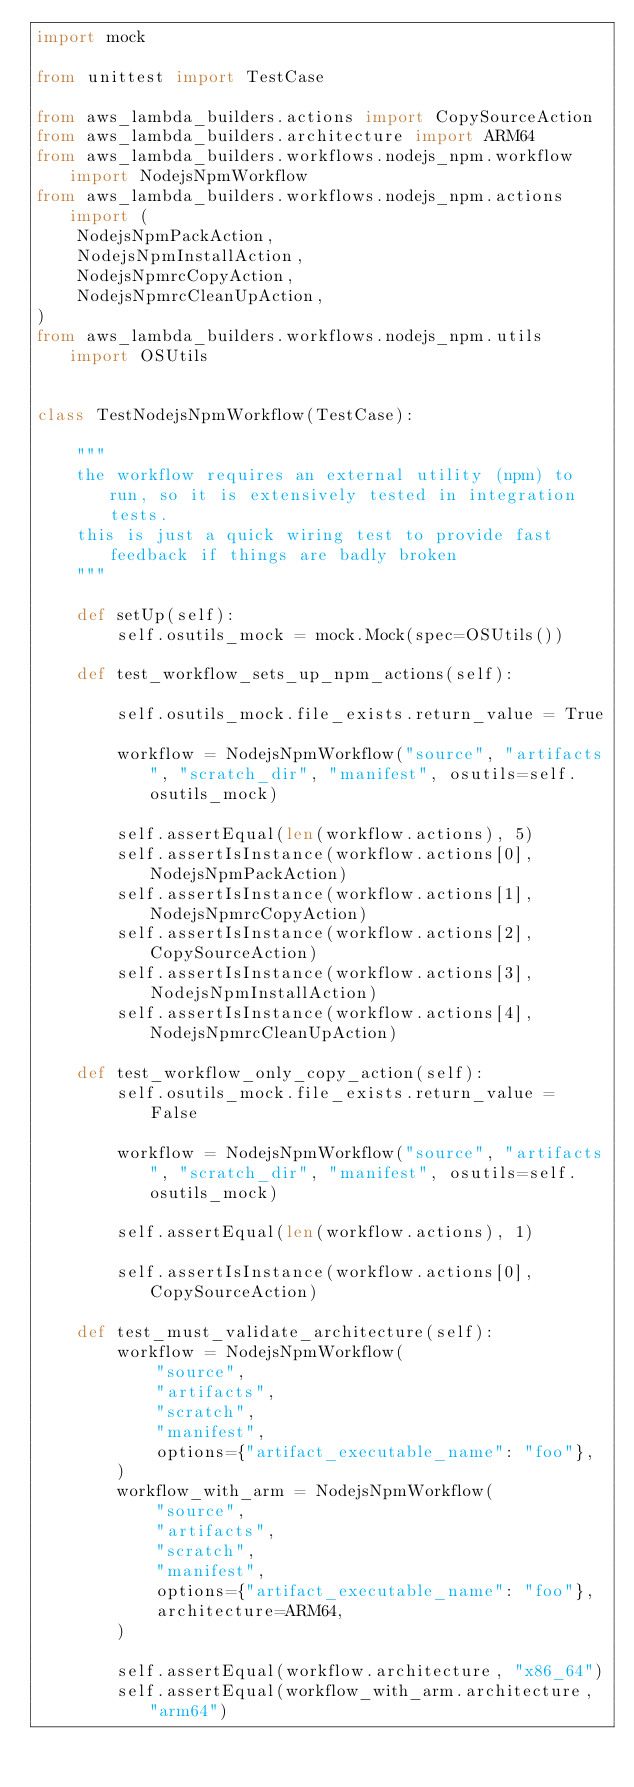<code> <loc_0><loc_0><loc_500><loc_500><_Python_>import mock

from unittest import TestCase

from aws_lambda_builders.actions import CopySourceAction
from aws_lambda_builders.architecture import ARM64
from aws_lambda_builders.workflows.nodejs_npm.workflow import NodejsNpmWorkflow
from aws_lambda_builders.workflows.nodejs_npm.actions import (
    NodejsNpmPackAction,
    NodejsNpmInstallAction,
    NodejsNpmrcCopyAction,
    NodejsNpmrcCleanUpAction,
)
from aws_lambda_builders.workflows.nodejs_npm.utils import OSUtils


class TestNodejsNpmWorkflow(TestCase):

    """
    the workflow requires an external utility (npm) to run, so it is extensively tested in integration tests.
    this is just a quick wiring test to provide fast feedback if things are badly broken
    """

    def setUp(self):
        self.osutils_mock = mock.Mock(spec=OSUtils())

    def test_workflow_sets_up_npm_actions(self):

        self.osutils_mock.file_exists.return_value = True

        workflow = NodejsNpmWorkflow("source", "artifacts", "scratch_dir", "manifest", osutils=self.osutils_mock)

        self.assertEqual(len(workflow.actions), 5)
        self.assertIsInstance(workflow.actions[0], NodejsNpmPackAction)
        self.assertIsInstance(workflow.actions[1], NodejsNpmrcCopyAction)
        self.assertIsInstance(workflow.actions[2], CopySourceAction)
        self.assertIsInstance(workflow.actions[3], NodejsNpmInstallAction)
        self.assertIsInstance(workflow.actions[4], NodejsNpmrcCleanUpAction)

    def test_workflow_only_copy_action(self):
        self.osutils_mock.file_exists.return_value = False

        workflow = NodejsNpmWorkflow("source", "artifacts", "scratch_dir", "manifest", osutils=self.osutils_mock)

        self.assertEqual(len(workflow.actions), 1)

        self.assertIsInstance(workflow.actions[0], CopySourceAction)

    def test_must_validate_architecture(self):
        workflow = NodejsNpmWorkflow(
            "source",
            "artifacts",
            "scratch",
            "manifest",
            options={"artifact_executable_name": "foo"},
        )
        workflow_with_arm = NodejsNpmWorkflow(
            "source",
            "artifacts",
            "scratch",
            "manifest",
            options={"artifact_executable_name": "foo"},
            architecture=ARM64,
        )

        self.assertEqual(workflow.architecture, "x86_64")
        self.assertEqual(workflow_with_arm.architecture, "arm64")
</code> 